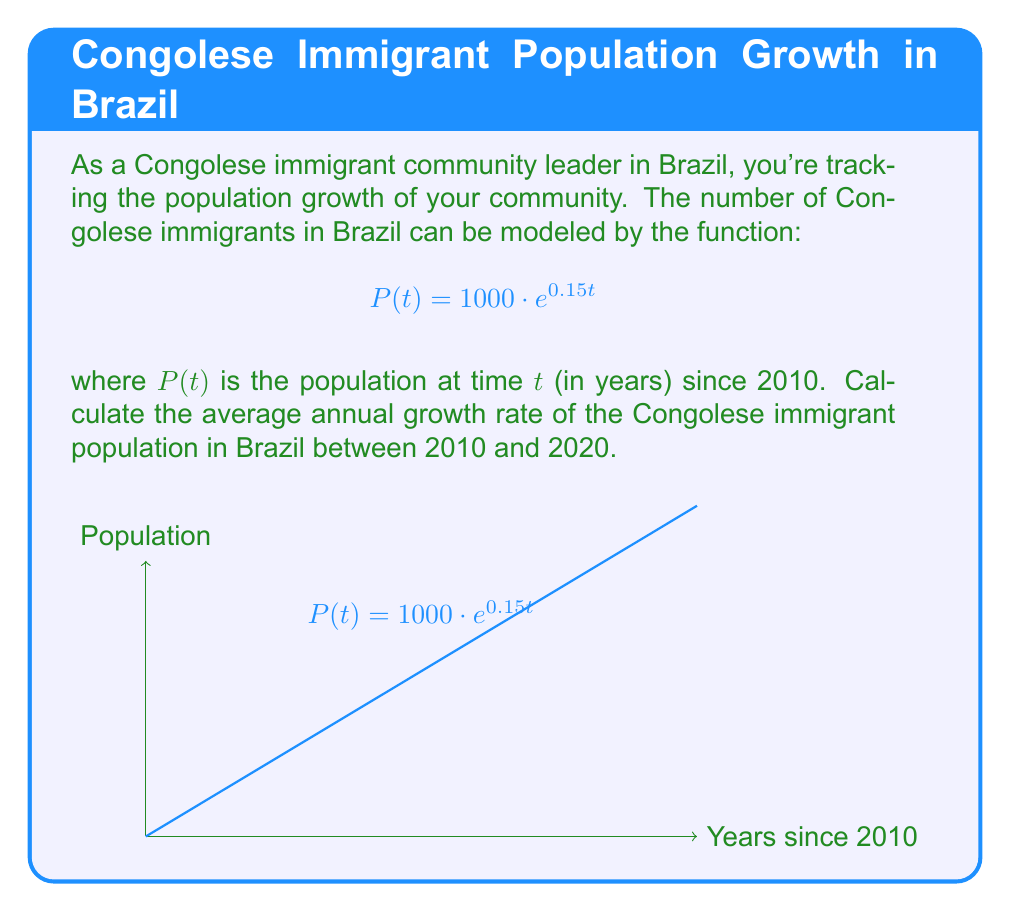Solve this math problem. To solve this problem, we'll follow these steps:

1) The average annual growth rate $r$ can be calculated using the formula:

   $$r = \left(\frac{P_n}{P_0}\right)^{\frac{1}{n}} - 1$$

   where $P_n$ is the population after $n$ years, $P_0$ is the initial population, and $n$ is the number of years.

2) We need to find $P_0$ (population in 2010) and $P_{10}$ (population in 2020):

   $P_0 = P(0) = 1000 \cdot e^{0.15 \cdot 0} = 1000$
   $P_{10} = P(10) = 1000 \cdot e^{0.15 \cdot 10} = 1000 \cdot e^{1.5}$

3) Now we can plug these values into our formula:

   $$r = \left(\frac{1000 \cdot e^{1.5}}{1000}\right)^{\frac{1}{10}} - 1$$

4) Simplify:

   $$r = \left(e^{1.5}\right)^{\frac{1}{10}} - 1 = e^{0.15} - 1$$

5) Calculate:

   $$r = e^{0.15} - 1 \approx 0.1618 \text{ or } 16.18\%$$
Answer: 16.18% 